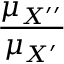<formula> <loc_0><loc_0><loc_500><loc_500>\frac { \mu _ { X ^ { \prime \prime } } } { \mu _ { X ^ { \prime } } }</formula> 